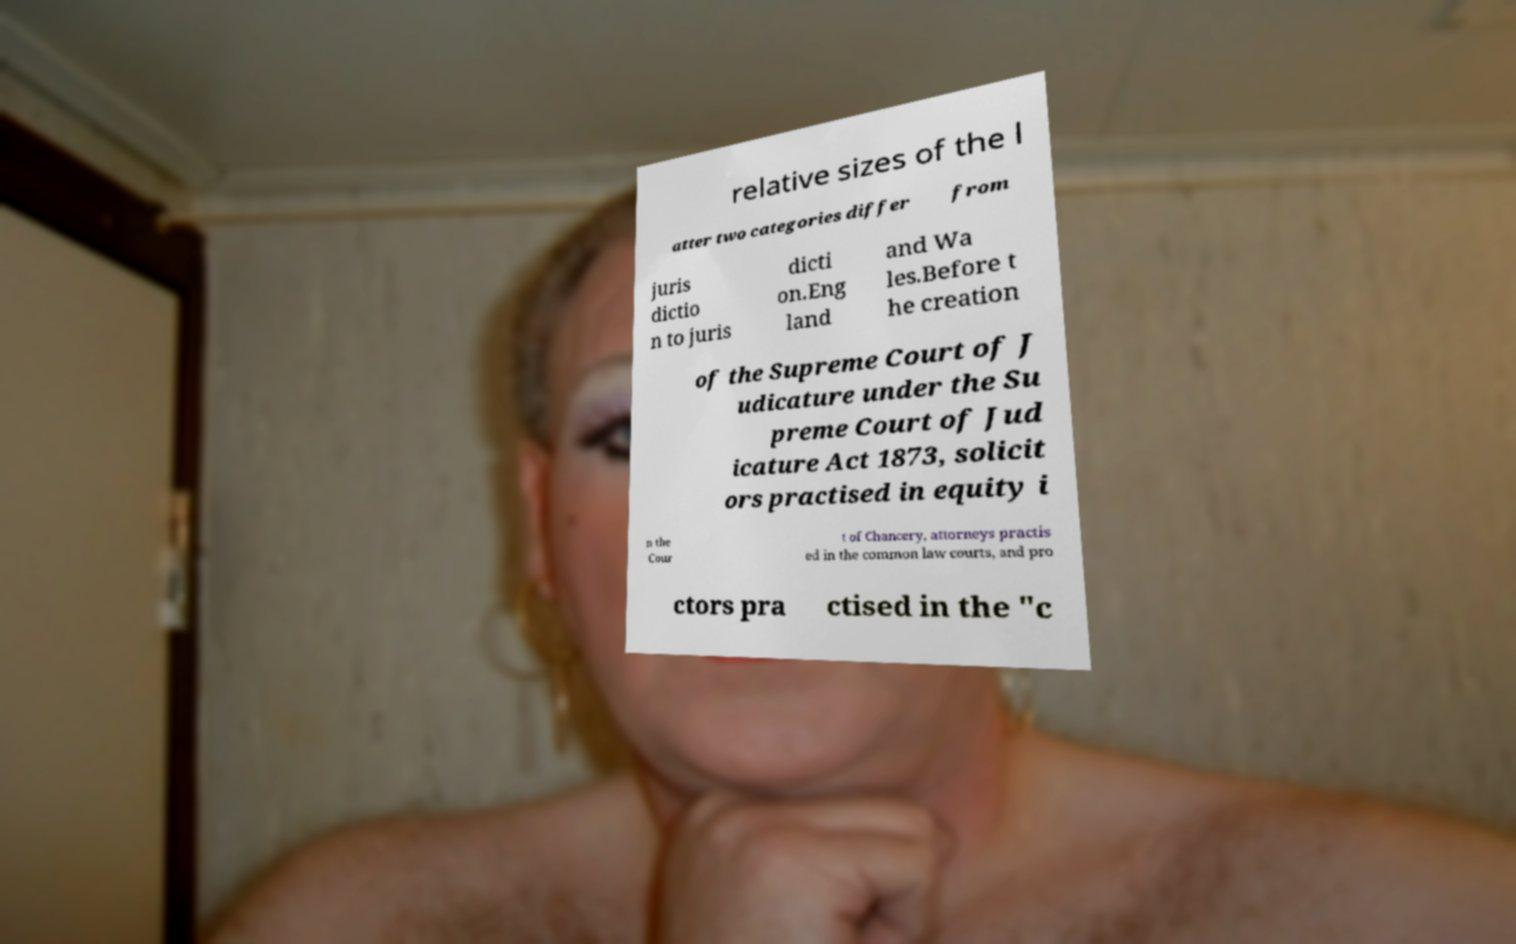Please read and relay the text visible in this image. What does it say? relative sizes of the l atter two categories differ from juris dictio n to juris dicti on.Eng land and Wa les.Before t he creation of the Supreme Court of J udicature under the Su preme Court of Jud icature Act 1873, solicit ors practised in equity i n the Cour t of Chancery, attorneys practis ed in the common law courts, and pro ctors pra ctised in the "c 